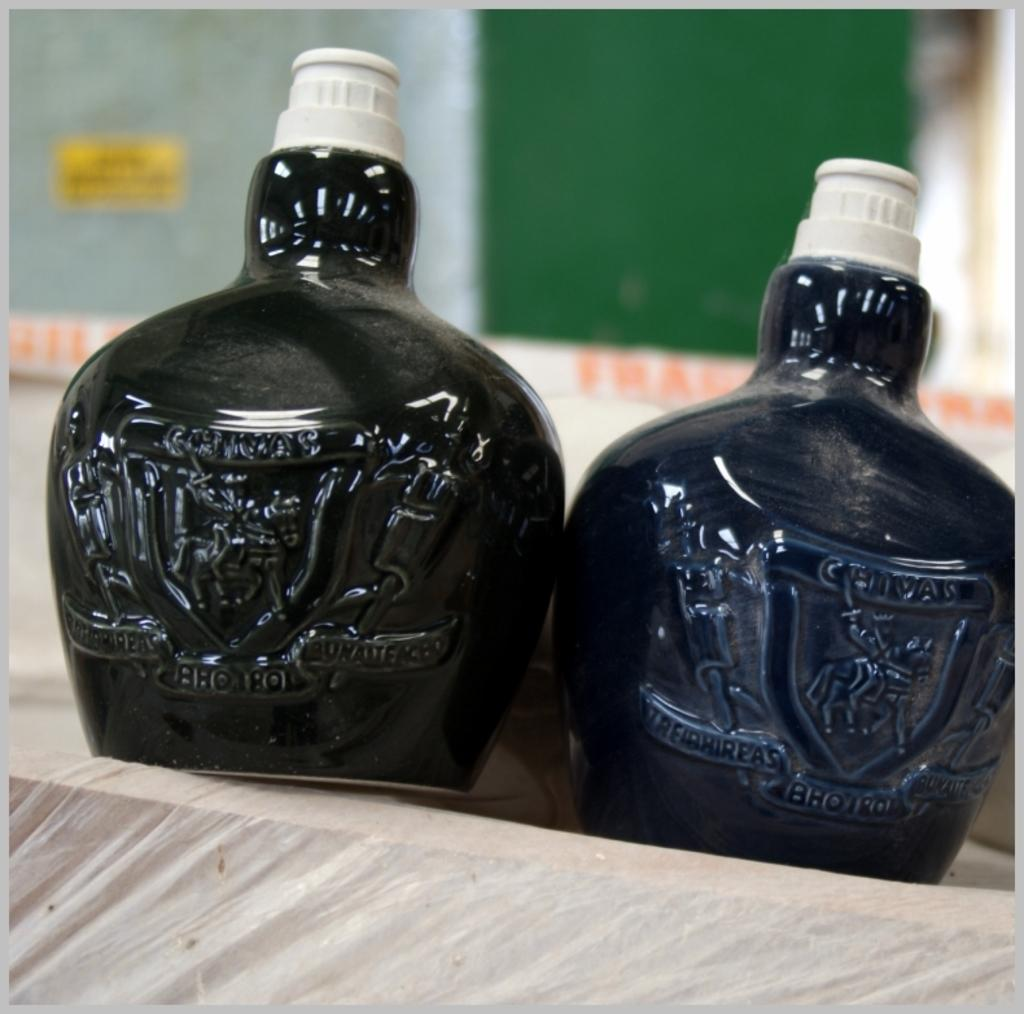<image>
Give a short and clear explanation of the subsequent image. Two small black bottles say Bhorol in them. 